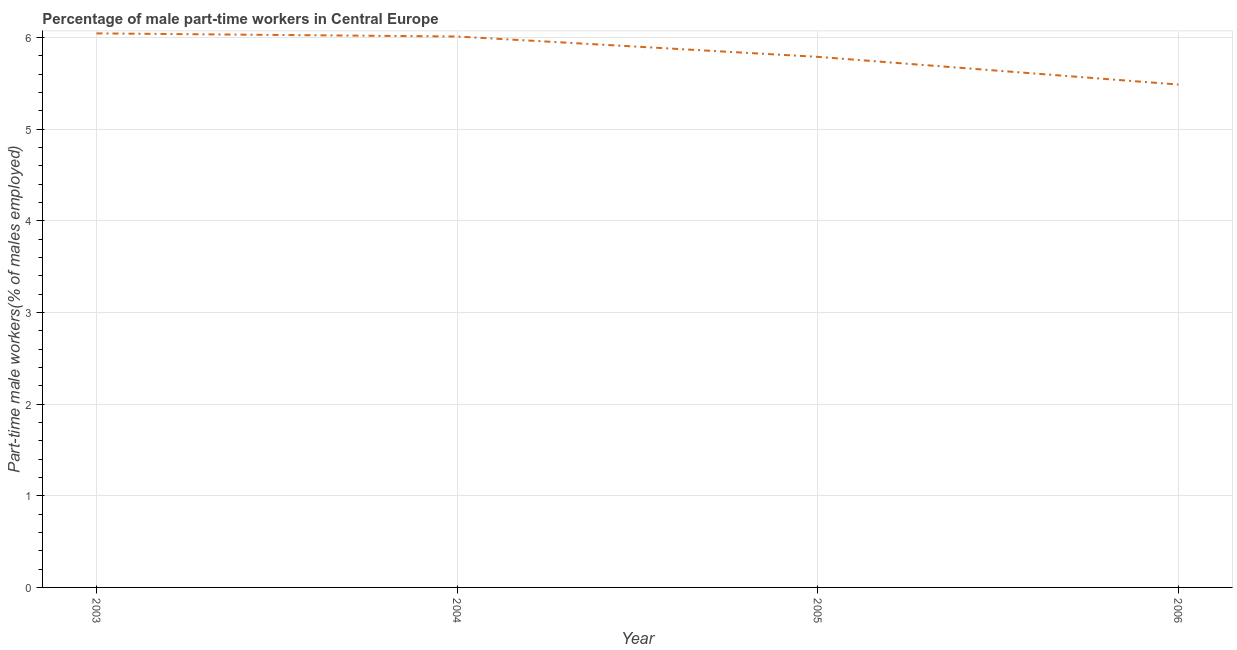What is the percentage of part-time male workers in 2006?
Your response must be concise. 5.49. Across all years, what is the maximum percentage of part-time male workers?
Provide a succinct answer. 6.04. Across all years, what is the minimum percentage of part-time male workers?
Offer a very short reply. 5.49. What is the sum of the percentage of part-time male workers?
Your answer should be very brief. 23.32. What is the difference between the percentage of part-time male workers in 2004 and 2005?
Give a very brief answer. 0.22. What is the average percentage of part-time male workers per year?
Make the answer very short. 5.83. What is the median percentage of part-time male workers?
Offer a terse response. 5.9. What is the ratio of the percentage of part-time male workers in 2003 to that in 2006?
Make the answer very short. 1.1. Is the percentage of part-time male workers in 2004 less than that in 2005?
Offer a terse response. No. Is the difference between the percentage of part-time male workers in 2003 and 2005 greater than the difference between any two years?
Ensure brevity in your answer.  No. What is the difference between the highest and the second highest percentage of part-time male workers?
Offer a terse response. 0.03. Is the sum of the percentage of part-time male workers in 2003 and 2006 greater than the maximum percentage of part-time male workers across all years?
Make the answer very short. Yes. What is the difference between the highest and the lowest percentage of part-time male workers?
Keep it short and to the point. 0.56. How many lines are there?
Keep it short and to the point. 1. Does the graph contain any zero values?
Offer a terse response. No. Does the graph contain grids?
Ensure brevity in your answer.  Yes. What is the title of the graph?
Your response must be concise. Percentage of male part-time workers in Central Europe. What is the label or title of the X-axis?
Your answer should be very brief. Year. What is the label or title of the Y-axis?
Provide a short and direct response. Part-time male workers(% of males employed). What is the Part-time male workers(% of males employed) of 2003?
Your response must be concise. 6.04. What is the Part-time male workers(% of males employed) in 2004?
Give a very brief answer. 6.01. What is the Part-time male workers(% of males employed) of 2005?
Your response must be concise. 5.79. What is the Part-time male workers(% of males employed) of 2006?
Your response must be concise. 5.49. What is the difference between the Part-time male workers(% of males employed) in 2003 and 2004?
Ensure brevity in your answer.  0.03. What is the difference between the Part-time male workers(% of males employed) in 2003 and 2005?
Keep it short and to the point. 0.26. What is the difference between the Part-time male workers(% of males employed) in 2003 and 2006?
Make the answer very short. 0.56. What is the difference between the Part-time male workers(% of males employed) in 2004 and 2005?
Offer a very short reply. 0.22. What is the difference between the Part-time male workers(% of males employed) in 2004 and 2006?
Offer a very short reply. 0.52. What is the difference between the Part-time male workers(% of males employed) in 2005 and 2006?
Give a very brief answer. 0.3. What is the ratio of the Part-time male workers(% of males employed) in 2003 to that in 2004?
Your answer should be compact. 1.01. What is the ratio of the Part-time male workers(% of males employed) in 2003 to that in 2005?
Keep it short and to the point. 1.04. What is the ratio of the Part-time male workers(% of males employed) in 2003 to that in 2006?
Your response must be concise. 1.1. What is the ratio of the Part-time male workers(% of males employed) in 2004 to that in 2005?
Make the answer very short. 1.04. What is the ratio of the Part-time male workers(% of males employed) in 2004 to that in 2006?
Your answer should be compact. 1.1. What is the ratio of the Part-time male workers(% of males employed) in 2005 to that in 2006?
Provide a succinct answer. 1.05. 